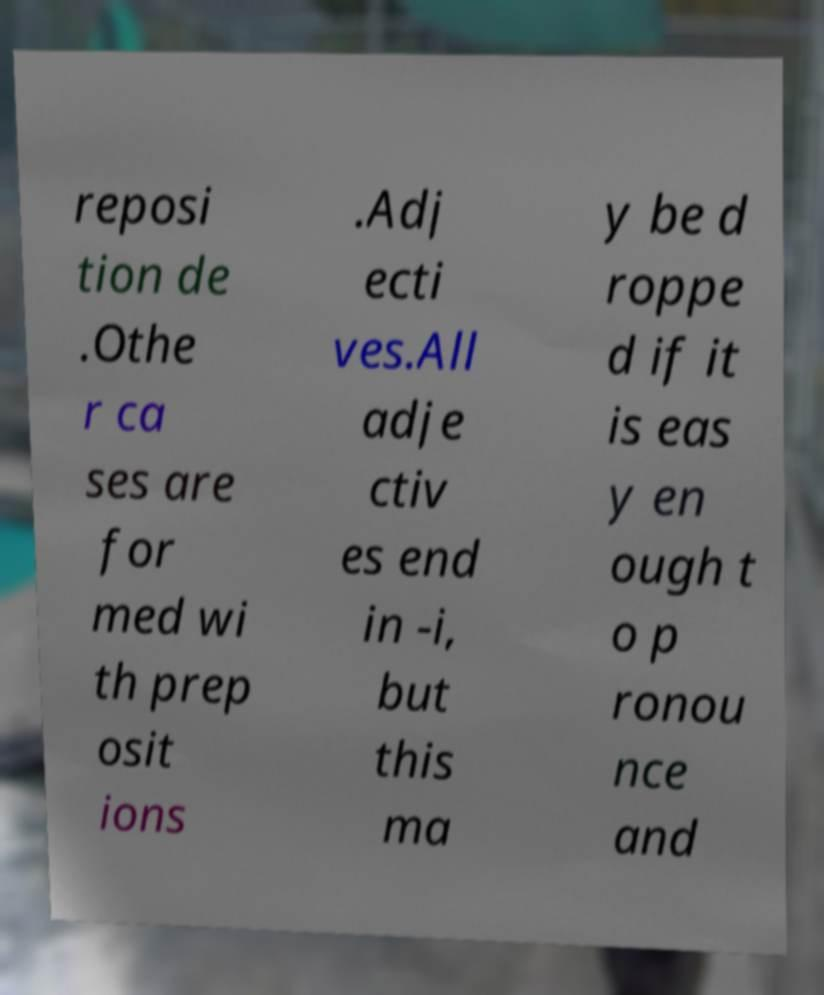For documentation purposes, I need the text within this image transcribed. Could you provide that? reposi tion de .Othe r ca ses are for med wi th prep osit ions .Adj ecti ves.All adje ctiv es end in -i, but this ma y be d roppe d if it is eas y en ough t o p ronou nce and 